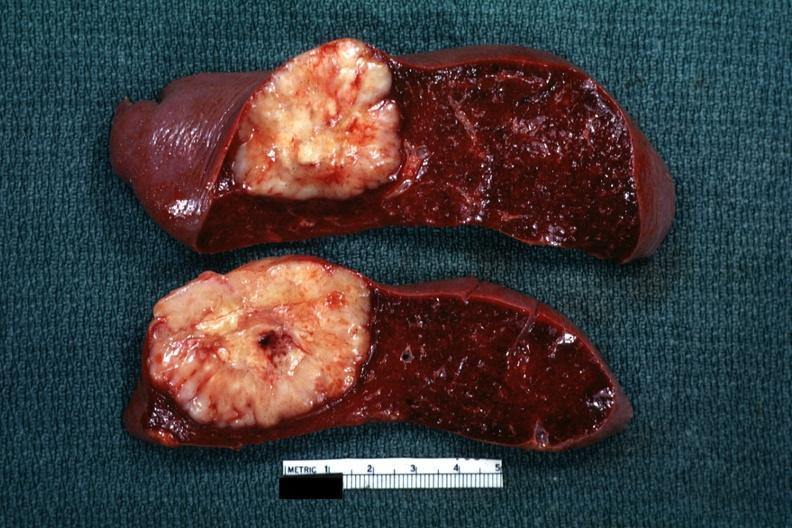was diagnosis reticulum cell sarcoma?
Answer the question using a single word or phrase. Yes 